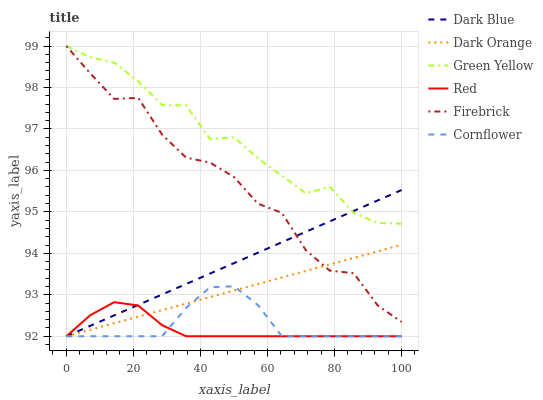Does Dark Orange have the minimum area under the curve?
Answer yes or no. No. Does Dark Orange have the maximum area under the curve?
Answer yes or no. No. Is Dark Orange the smoothest?
Answer yes or no. No. Is Dark Orange the roughest?
Answer yes or no. No. Does Firebrick have the lowest value?
Answer yes or no. No. Does Dark Orange have the highest value?
Answer yes or no. No. Is Cornflower less than Green Yellow?
Answer yes or no. Yes. Is Green Yellow greater than Red?
Answer yes or no. Yes. Does Cornflower intersect Green Yellow?
Answer yes or no. No. 